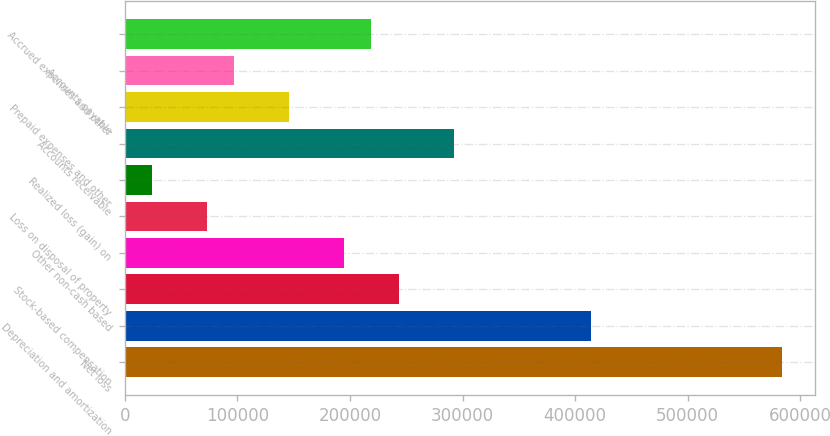<chart> <loc_0><loc_0><loc_500><loc_500><bar_chart><fcel>Net loss<fcel>Depreciation and amortization<fcel>Stock-based compensation<fcel>Other non-cash based<fcel>Loss on disposal of property<fcel>Realized loss (gain) on<fcel>Accounts receivable<fcel>Prepaid expenses and other<fcel>Accounts payable<fcel>Accrued expenses and other<nl><fcel>584101<fcel>413756<fcel>243410<fcel>194740<fcel>73064.3<fcel>24394.1<fcel>292080<fcel>146070<fcel>97399.4<fcel>219075<nl></chart> 